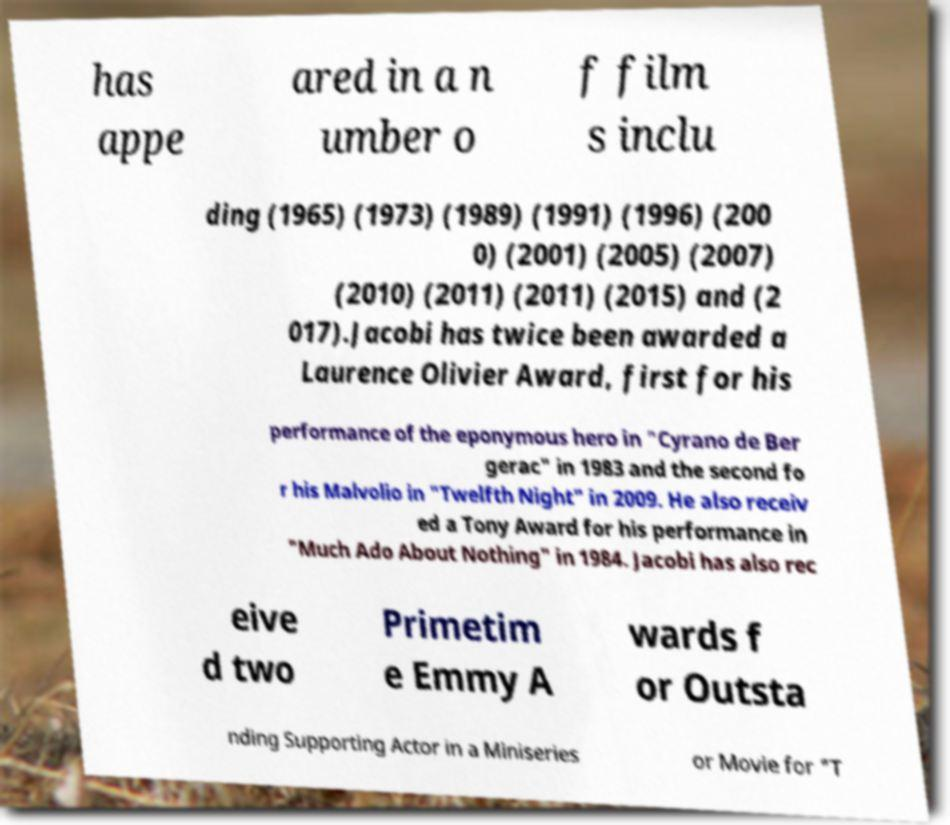Can you accurately transcribe the text from the provided image for me? has appe ared in a n umber o f film s inclu ding (1965) (1973) (1989) (1991) (1996) (200 0) (2001) (2005) (2007) (2010) (2011) (2011) (2015) and (2 017).Jacobi has twice been awarded a Laurence Olivier Award, first for his performance of the eponymous hero in "Cyrano de Ber gerac" in 1983 and the second fo r his Malvolio in "Twelfth Night" in 2009. He also receiv ed a Tony Award for his performance in "Much Ado About Nothing" in 1984. Jacobi has also rec eive d two Primetim e Emmy A wards f or Outsta nding Supporting Actor in a Miniseries or Movie for "T 